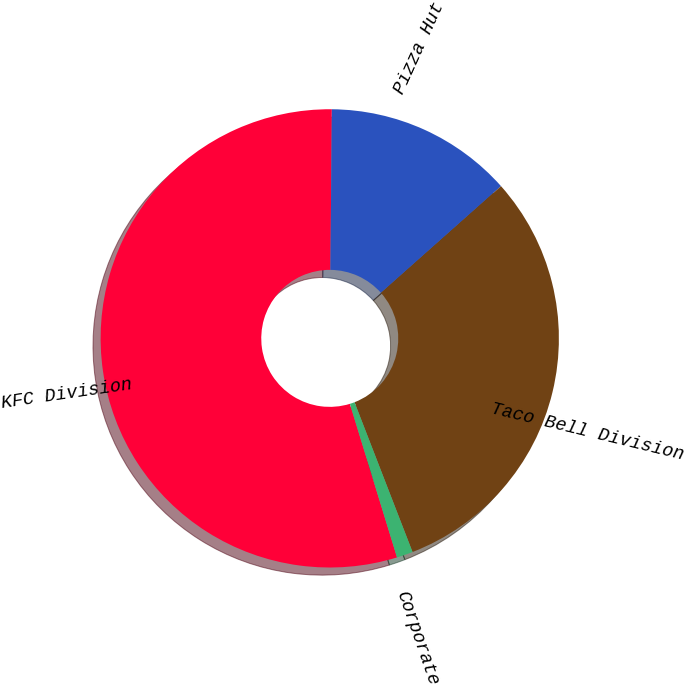Convert chart to OTSL. <chart><loc_0><loc_0><loc_500><loc_500><pie_chart><fcel>KFC Division<fcel>Pizza Hut Division<fcel>Taco Bell Division<fcel>Corporate<nl><fcel>54.89%<fcel>13.29%<fcel>30.68%<fcel>1.14%<nl></chart> 